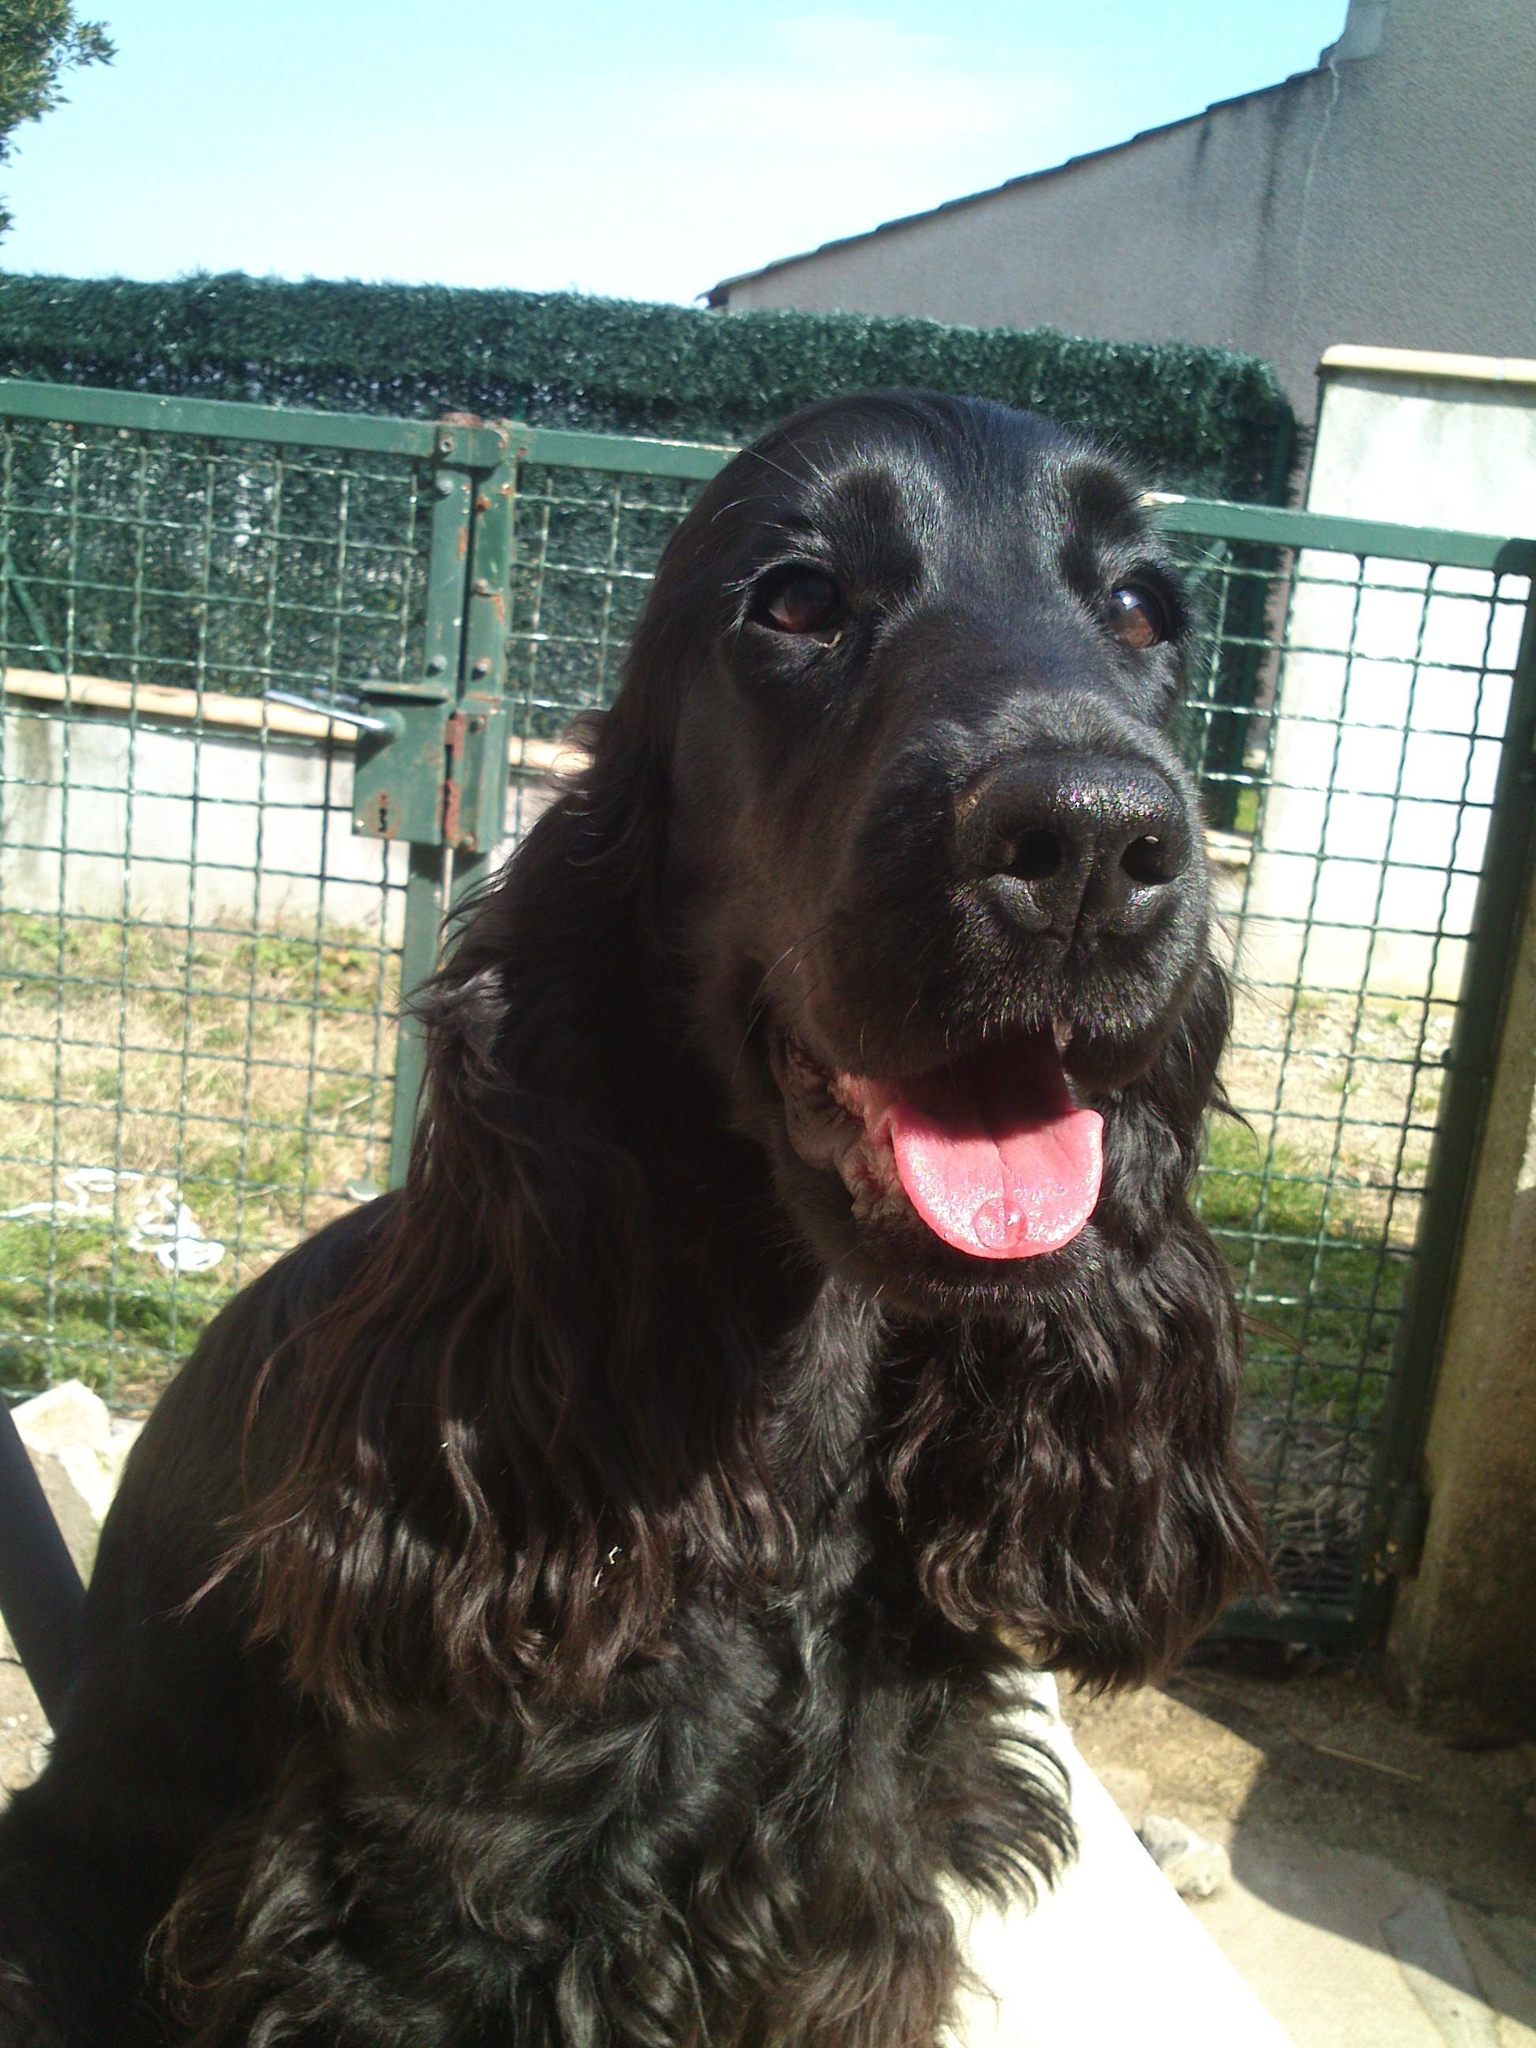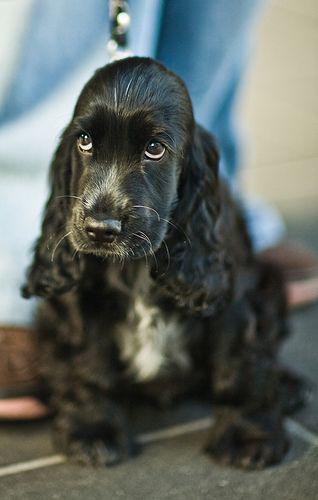The first image is the image on the left, the second image is the image on the right. For the images shown, is this caption "At least one dog is being held in someone's hands." true? Answer yes or no. No. The first image is the image on the left, the second image is the image on the right. Considering the images on both sides, is "the right pic has human shoes in it" valid? Answer yes or no. Yes. 